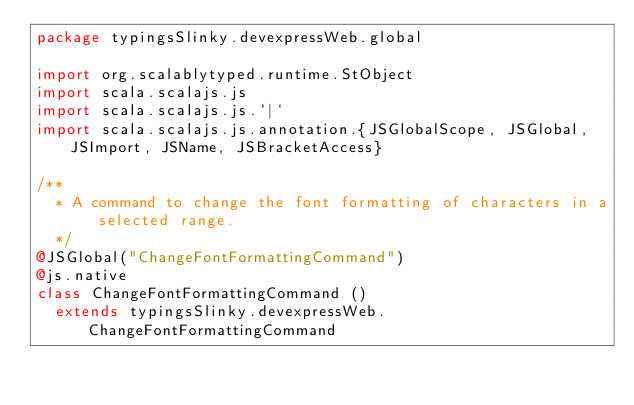Convert code to text. <code><loc_0><loc_0><loc_500><loc_500><_Scala_>package typingsSlinky.devexpressWeb.global

import org.scalablytyped.runtime.StObject
import scala.scalajs.js
import scala.scalajs.js.`|`
import scala.scalajs.js.annotation.{JSGlobalScope, JSGlobal, JSImport, JSName, JSBracketAccess}

/**
  * A command to change the font formatting of characters in a selected range.
  */
@JSGlobal("ChangeFontFormattingCommand")
@js.native
class ChangeFontFormattingCommand ()
  extends typingsSlinky.devexpressWeb.ChangeFontFormattingCommand
</code> 